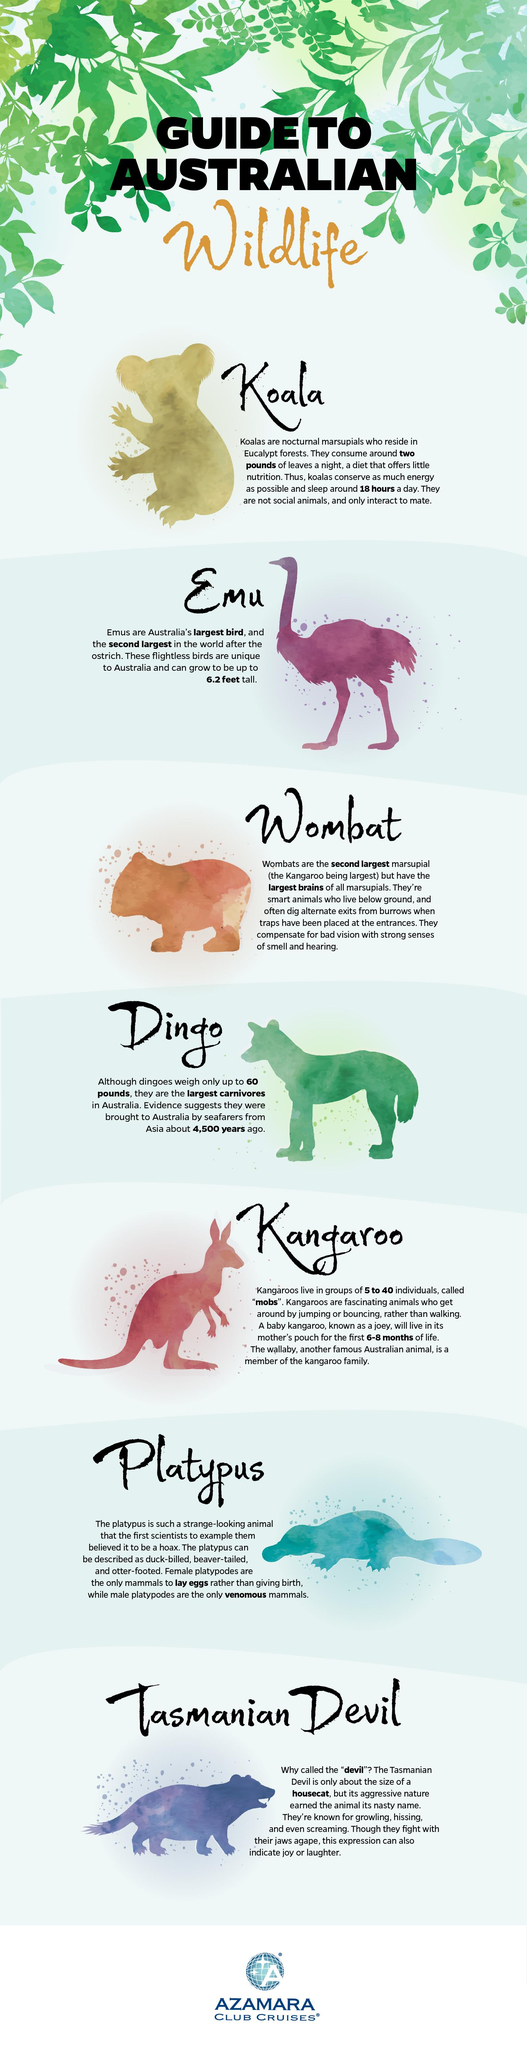Identify some key points in this picture. There are a total of 7 different animals that are considered to be a part of Australian wildlife. 